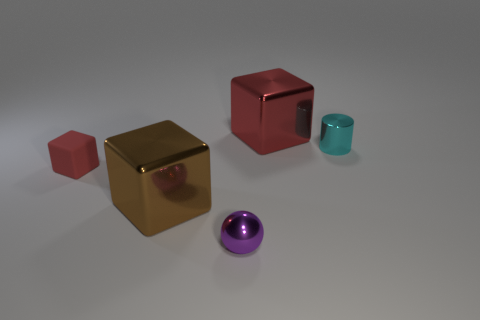There is a metal block in front of the red thing behind the red matte cube; how big is it?
Offer a terse response. Large. There is a small red thing that is the same shape as the large brown object; what is it made of?
Your answer should be very brief. Rubber. How many cyan metallic things have the same size as the matte block?
Provide a short and direct response. 1. Do the red shiny cube and the matte cube have the same size?
Your answer should be very brief. No. There is a block that is to the right of the small red matte object and in front of the large red shiny thing; what is its size?
Give a very brief answer. Large. Is the number of metal blocks that are in front of the cyan cylinder greater than the number of cyan things in front of the purple ball?
Your response must be concise. Yes. The other matte object that is the same shape as the big brown thing is what color?
Ensure brevity in your answer.  Red. There is a cube that is behind the small cube; is it the same color as the rubber object?
Make the answer very short. Yes. What number of small purple metallic objects are there?
Offer a very short reply. 1. Are the red thing behind the small rubber thing and the cyan thing made of the same material?
Make the answer very short. Yes. 